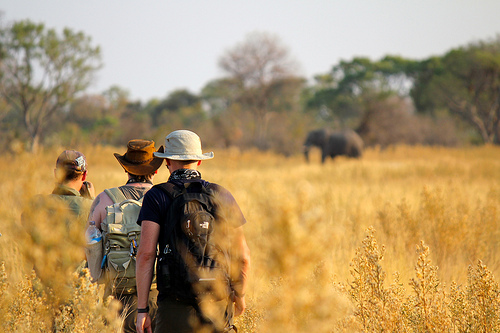Who is standing? The men are standing. 